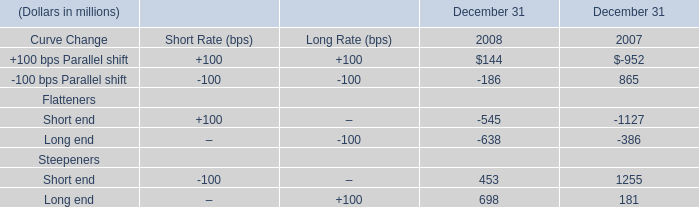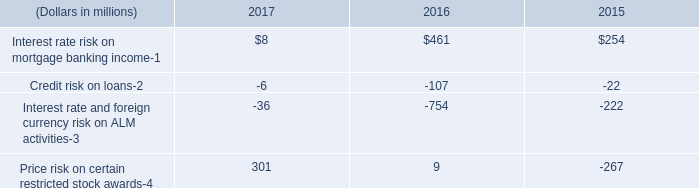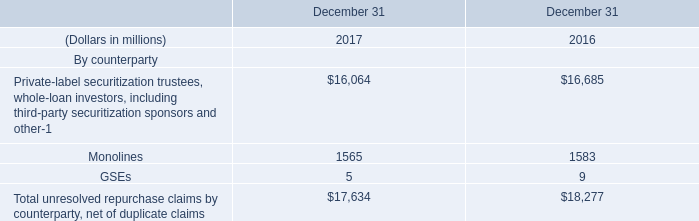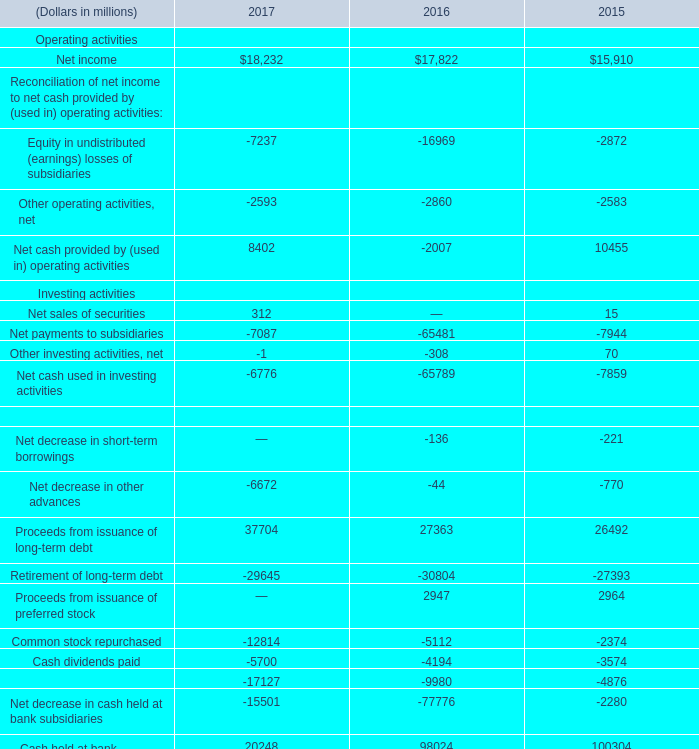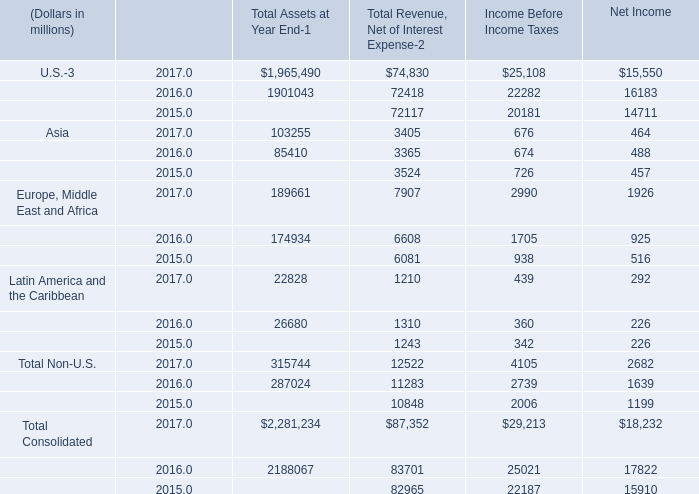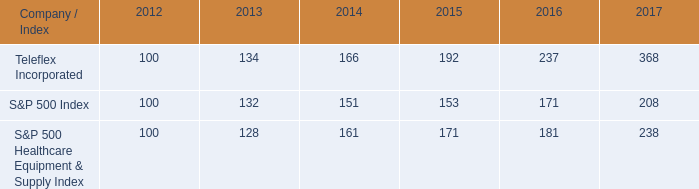What is the average amount of Monolines of December 31 2017, and Cash dividends paid Financing activities of 2016 ? 
Computations: ((1565.0 + 4194.0) / 2)
Answer: 2879.5. 